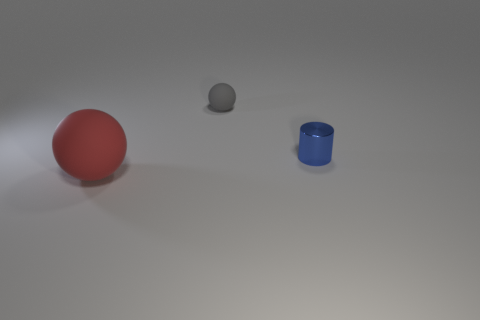Add 3 red balls. How many objects exist? 6 Subtract all cylinders. How many objects are left? 2 Add 2 matte things. How many matte things exist? 4 Subtract 1 red balls. How many objects are left? 2 Subtract all small things. Subtract all small balls. How many objects are left? 0 Add 3 small blue objects. How many small blue objects are left? 4 